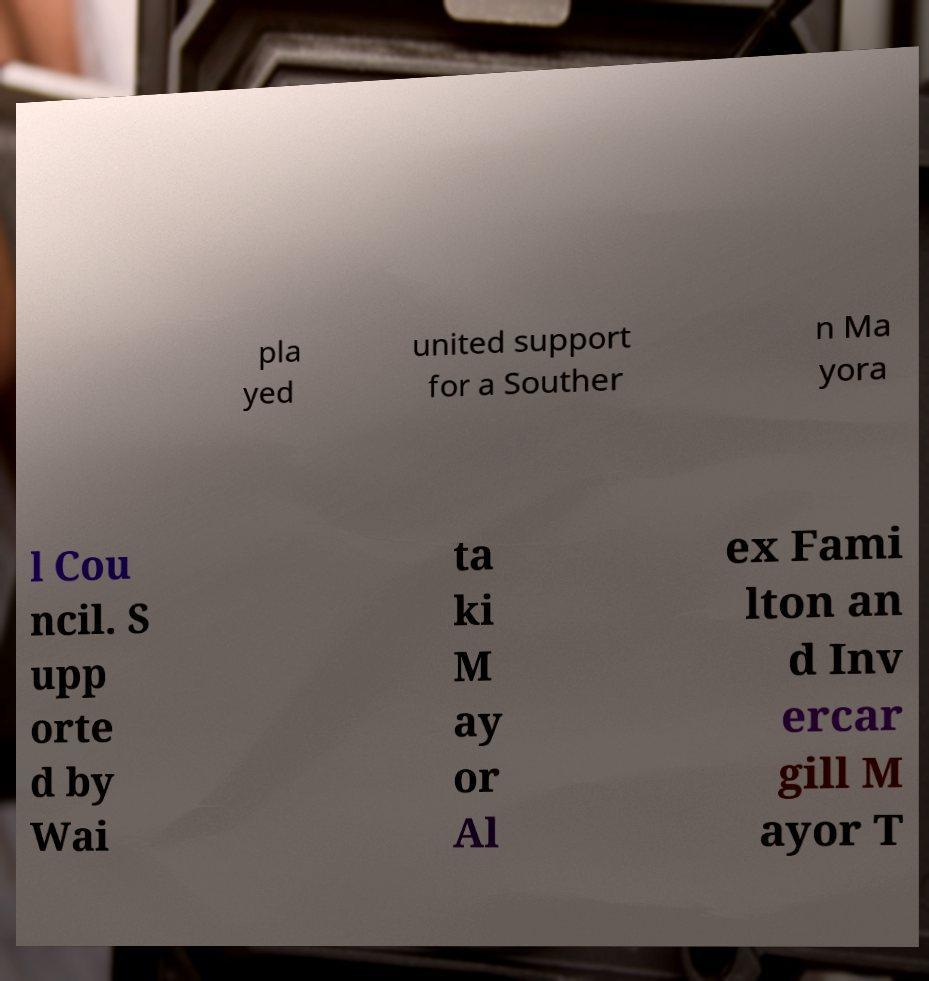Please read and relay the text visible in this image. What does it say? pla yed united support for a Souther n Ma yora l Cou ncil. S upp orte d by Wai ta ki M ay or Al ex Fami lton an d Inv ercar gill M ayor T 